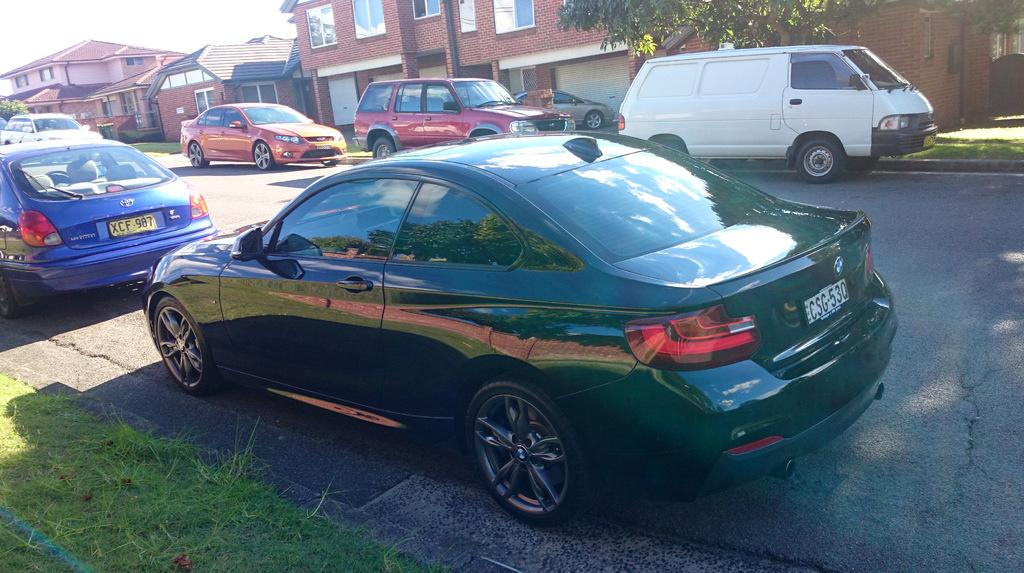What color is the car that is parked in the image? There is a black car in the image. Where is the black car located in the image? The car is parked on the road side. Can you see any other cars in the image? Yes, there are other cars visible behind the black car. What can be seen in the background of the image? There are brown buildings in the background of the image. What type of meal is being prepared in the car? There is no meal being prepared in the car; it is a parked vehicle. Is the crook hiding behind the brown buildings in the image? There is no crook or any indication of criminal activity in the image; it simply shows a black car parked on the road side with brown buildings in the background. 